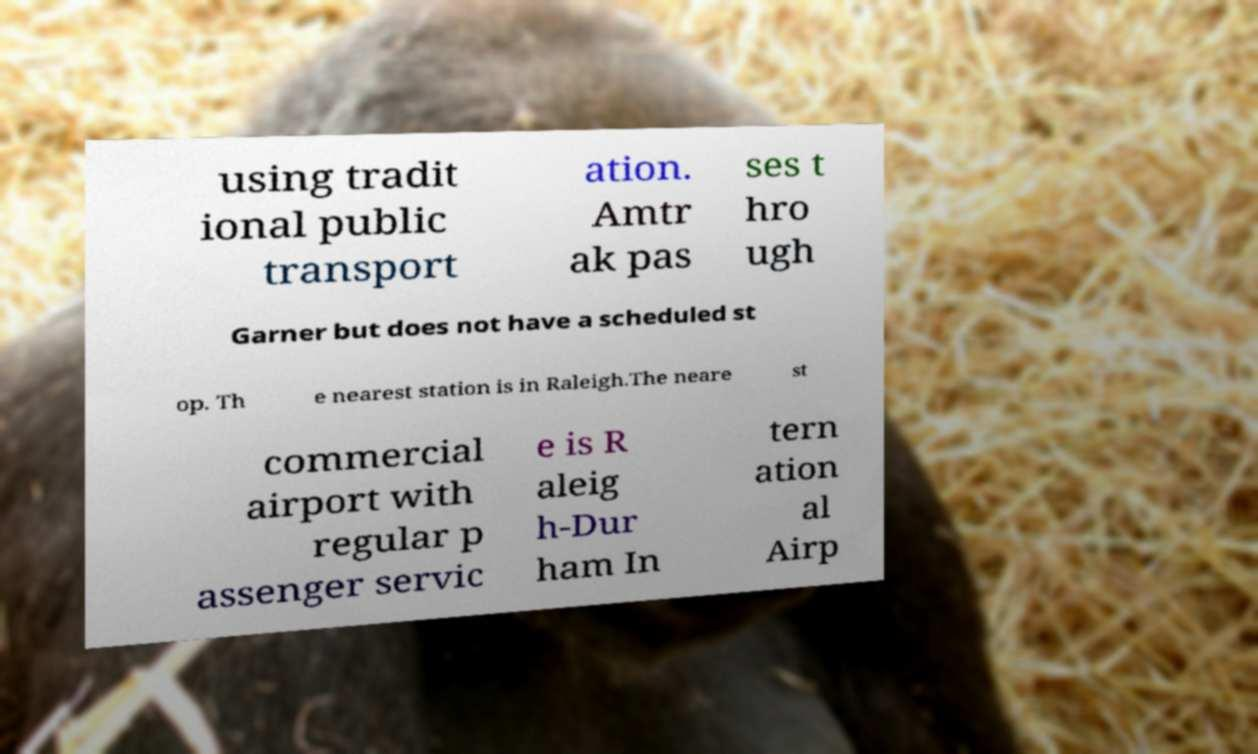Can you accurately transcribe the text from the provided image for me? using tradit ional public transport ation. Amtr ak pas ses t hro ugh Garner but does not have a scheduled st op. Th e nearest station is in Raleigh.The neare st commercial airport with regular p assenger servic e is R aleig h-Dur ham In tern ation al Airp 